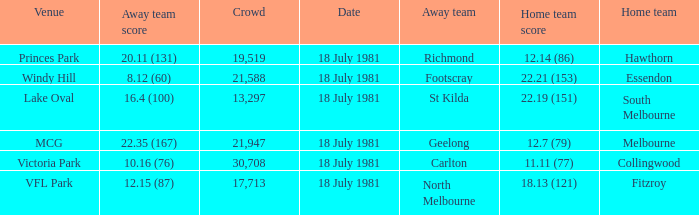What was the away team that played against Fitzroy? North Melbourne. 